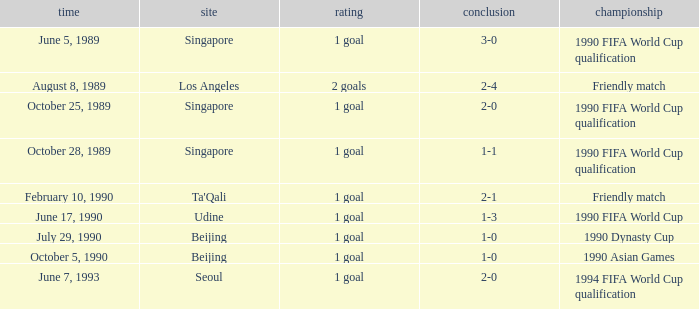What is the competition at the ta'qali venue? Friendly match. 